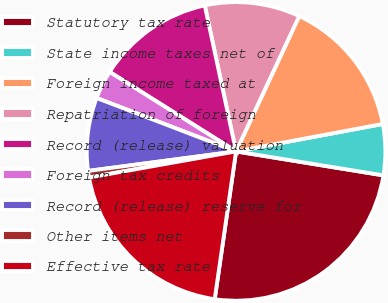<chart> <loc_0><loc_0><loc_500><loc_500><pie_chart><fcel>Statutory tax rate<fcel>State income taxes net of<fcel>Foreign income taxed at<fcel>Repatriation of foreign<fcel>Record (release) valuation<fcel>Foreign tax credits<fcel>Record (release) reserve for<fcel>Other items net<fcel>Effective tax rate<nl><fcel>24.72%<fcel>5.51%<fcel>15.11%<fcel>10.31%<fcel>12.71%<fcel>3.11%<fcel>7.91%<fcel>0.71%<fcel>19.92%<nl></chart> 